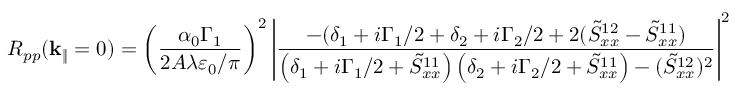Convert formula to latex. <formula><loc_0><loc_0><loc_500><loc_500>R _ { p p } ( k _ { \| } = 0 ) = \left ( \frac { \alpha _ { 0 } \Gamma _ { 1 } } { 2 A \lambda \varepsilon _ { 0 } / \pi } \right ) ^ { 2 } \left | \frac { - ( \delta _ { 1 } + i \Gamma _ { 1 } / 2 + \delta _ { 2 } + i \Gamma _ { 2 } / 2 + 2 ( \tilde { S } _ { x x } ^ { 1 2 } - \tilde { S } _ { x x } ^ { 1 1 } ) } { \left ( \delta _ { 1 } + i \Gamma _ { 1 } / 2 + \tilde { S } _ { x x } ^ { 1 1 } \right ) \left ( \delta _ { 2 } + i \Gamma _ { 2 } / 2 + \tilde { S } _ { x x } ^ { 1 1 } \right ) - ( \tilde { S } _ { x x } ^ { 1 2 } ) ^ { 2 } } \right | ^ { 2 }</formula> 